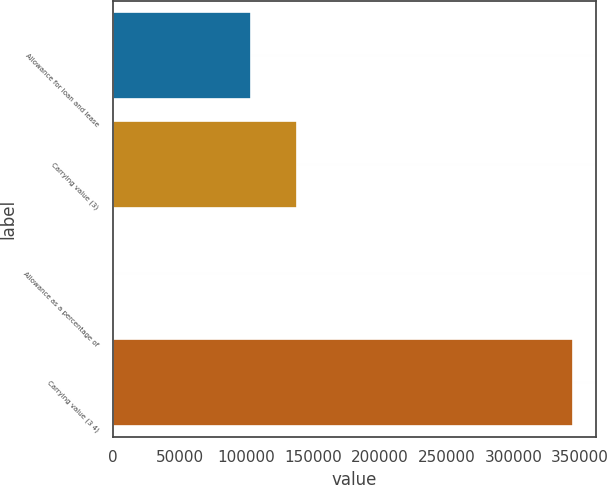Convert chart. <chart><loc_0><loc_0><loc_500><loc_500><bar_chart><fcel>Allowance for loan and lease<fcel>Carrying value (3)<fcel>Allowance as a percentage of<fcel>Carrying value (3 4)<nl><fcel>103448<fcel>137930<fcel>3.1<fcel>344821<nl></chart> 